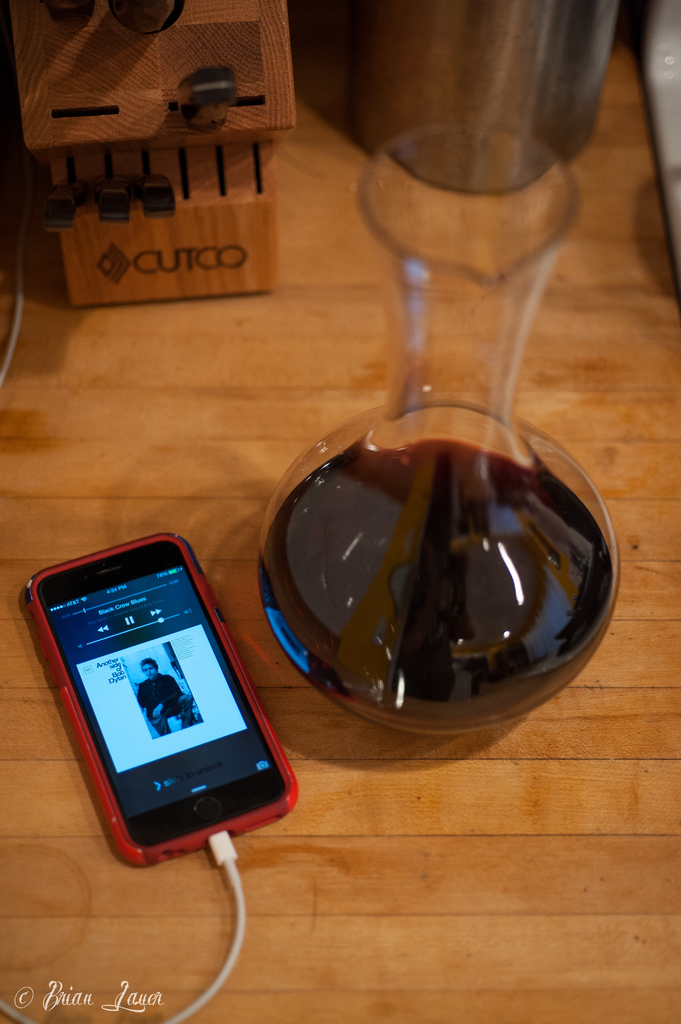What might be the occasion for using the wine decanter in this picture? The presence of the wine decanter suggests an occasion that calls for the enjoyment of wine, likely decanted to enhance its flavor and aroma, which could typically be during a dinner party or a special meal. 